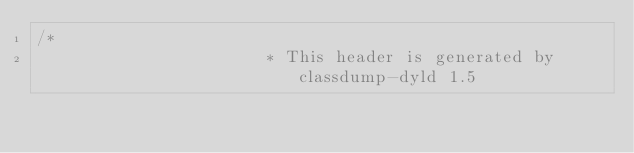<code> <loc_0><loc_0><loc_500><loc_500><_C_>/*
                       * This header is generated by classdump-dyld 1.5</code> 